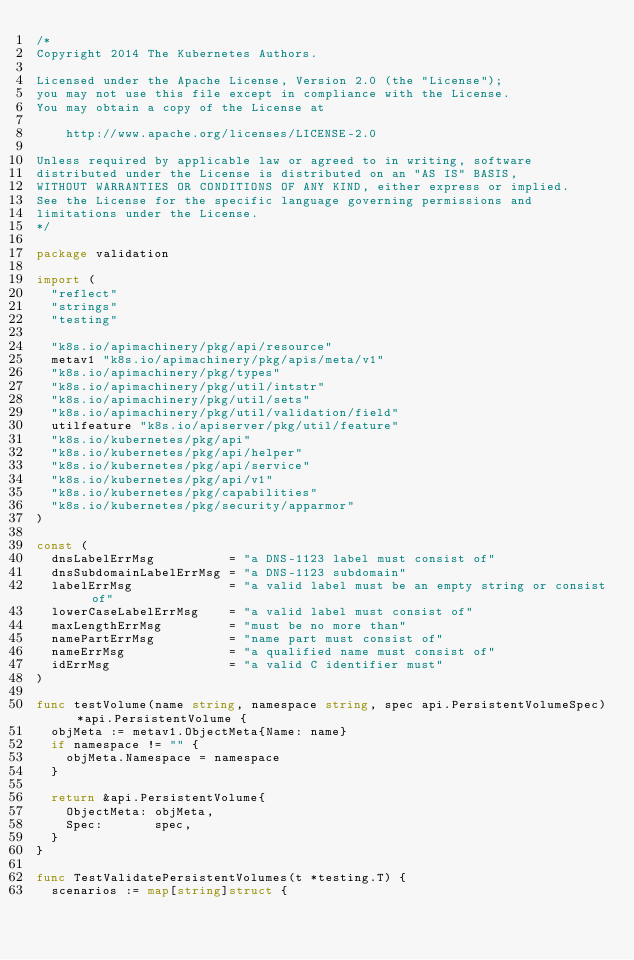Convert code to text. <code><loc_0><loc_0><loc_500><loc_500><_Go_>/*
Copyright 2014 The Kubernetes Authors.

Licensed under the Apache License, Version 2.0 (the "License");
you may not use this file except in compliance with the License.
You may obtain a copy of the License at

    http://www.apache.org/licenses/LICENSE-2.0

Unless required by applicable law or agreed to in writing, software
distributed under the License is distributed on an "AS IS" BASIS,
WITHOUT WARRANTIES OR CONDITIONS OF ANY KIND, either express or implied.
See the License for the specific language governing permissions and
limitations under the License.
*/

package validation

import (
	"reflect"
	"strings"
	"testing"

	"k8s.io/apimachinery/pkg/api/resource"
	metav1 "k8s.io/apimachinery/pkg/apis/meta/v1"
	"k8s.io/apimachinery/pkg/types"
	"k8s.io/apimachinery/pkg/util/intstr"
	"k8s.io/apimachinery/pkg/util/sets"
	"k8s.io/apimachinery/pkg/util/validation/field"
	utilfeature "k8s.io/apiserver/pkg/util/feature"
	"k8s.io/kubernetes/pkg/api"
	"k8s.io/kubernetes/pkg/api/helper"
	"k8s.io/kubernetes/pkg/api/service"
	"k8s.io/kubernetes/pkg/api/v1"
	"k8s.io/kubernetes/pkg/capabilities"
	"k8s.io/kubernetes/pkg/security/apparmor"
)

const (
	dnsLabelErrMsg          = "a DNS-1123 label must consist of"
	dnsSubdomainLabelErrMsg = "a DNS-1123 subdomain"
	labelErrMsg             = "a valid label must be an empty string or consist of"
	lowerCaseLabelErrMsg    = "a valid label must consist of"
	maxLengthErrMsg         = "must be no more than"
	namePartErrMsg          = "name part must consist of"
	nameErrMsg              = "a qualified name must consist of"
	idErrMsg                = "a valid C identifier must"
)

func testVolume(name string, namespace string, spec api.PersistentVolumeSpec) *api.PersistentVolume {
	objMeta := metav1.ObjectMeta{Name: name}
	if namespace != "" {
		objMeta.Namespace = namespace
	}

	return &api.PersistentVolume{
		ObjectMeta: objMeta,
		Spec:       spec,
	}
}

func TestValidatePersistentVolumes(t *testing.T) {
	scenarios := map[string]struct {</code> 